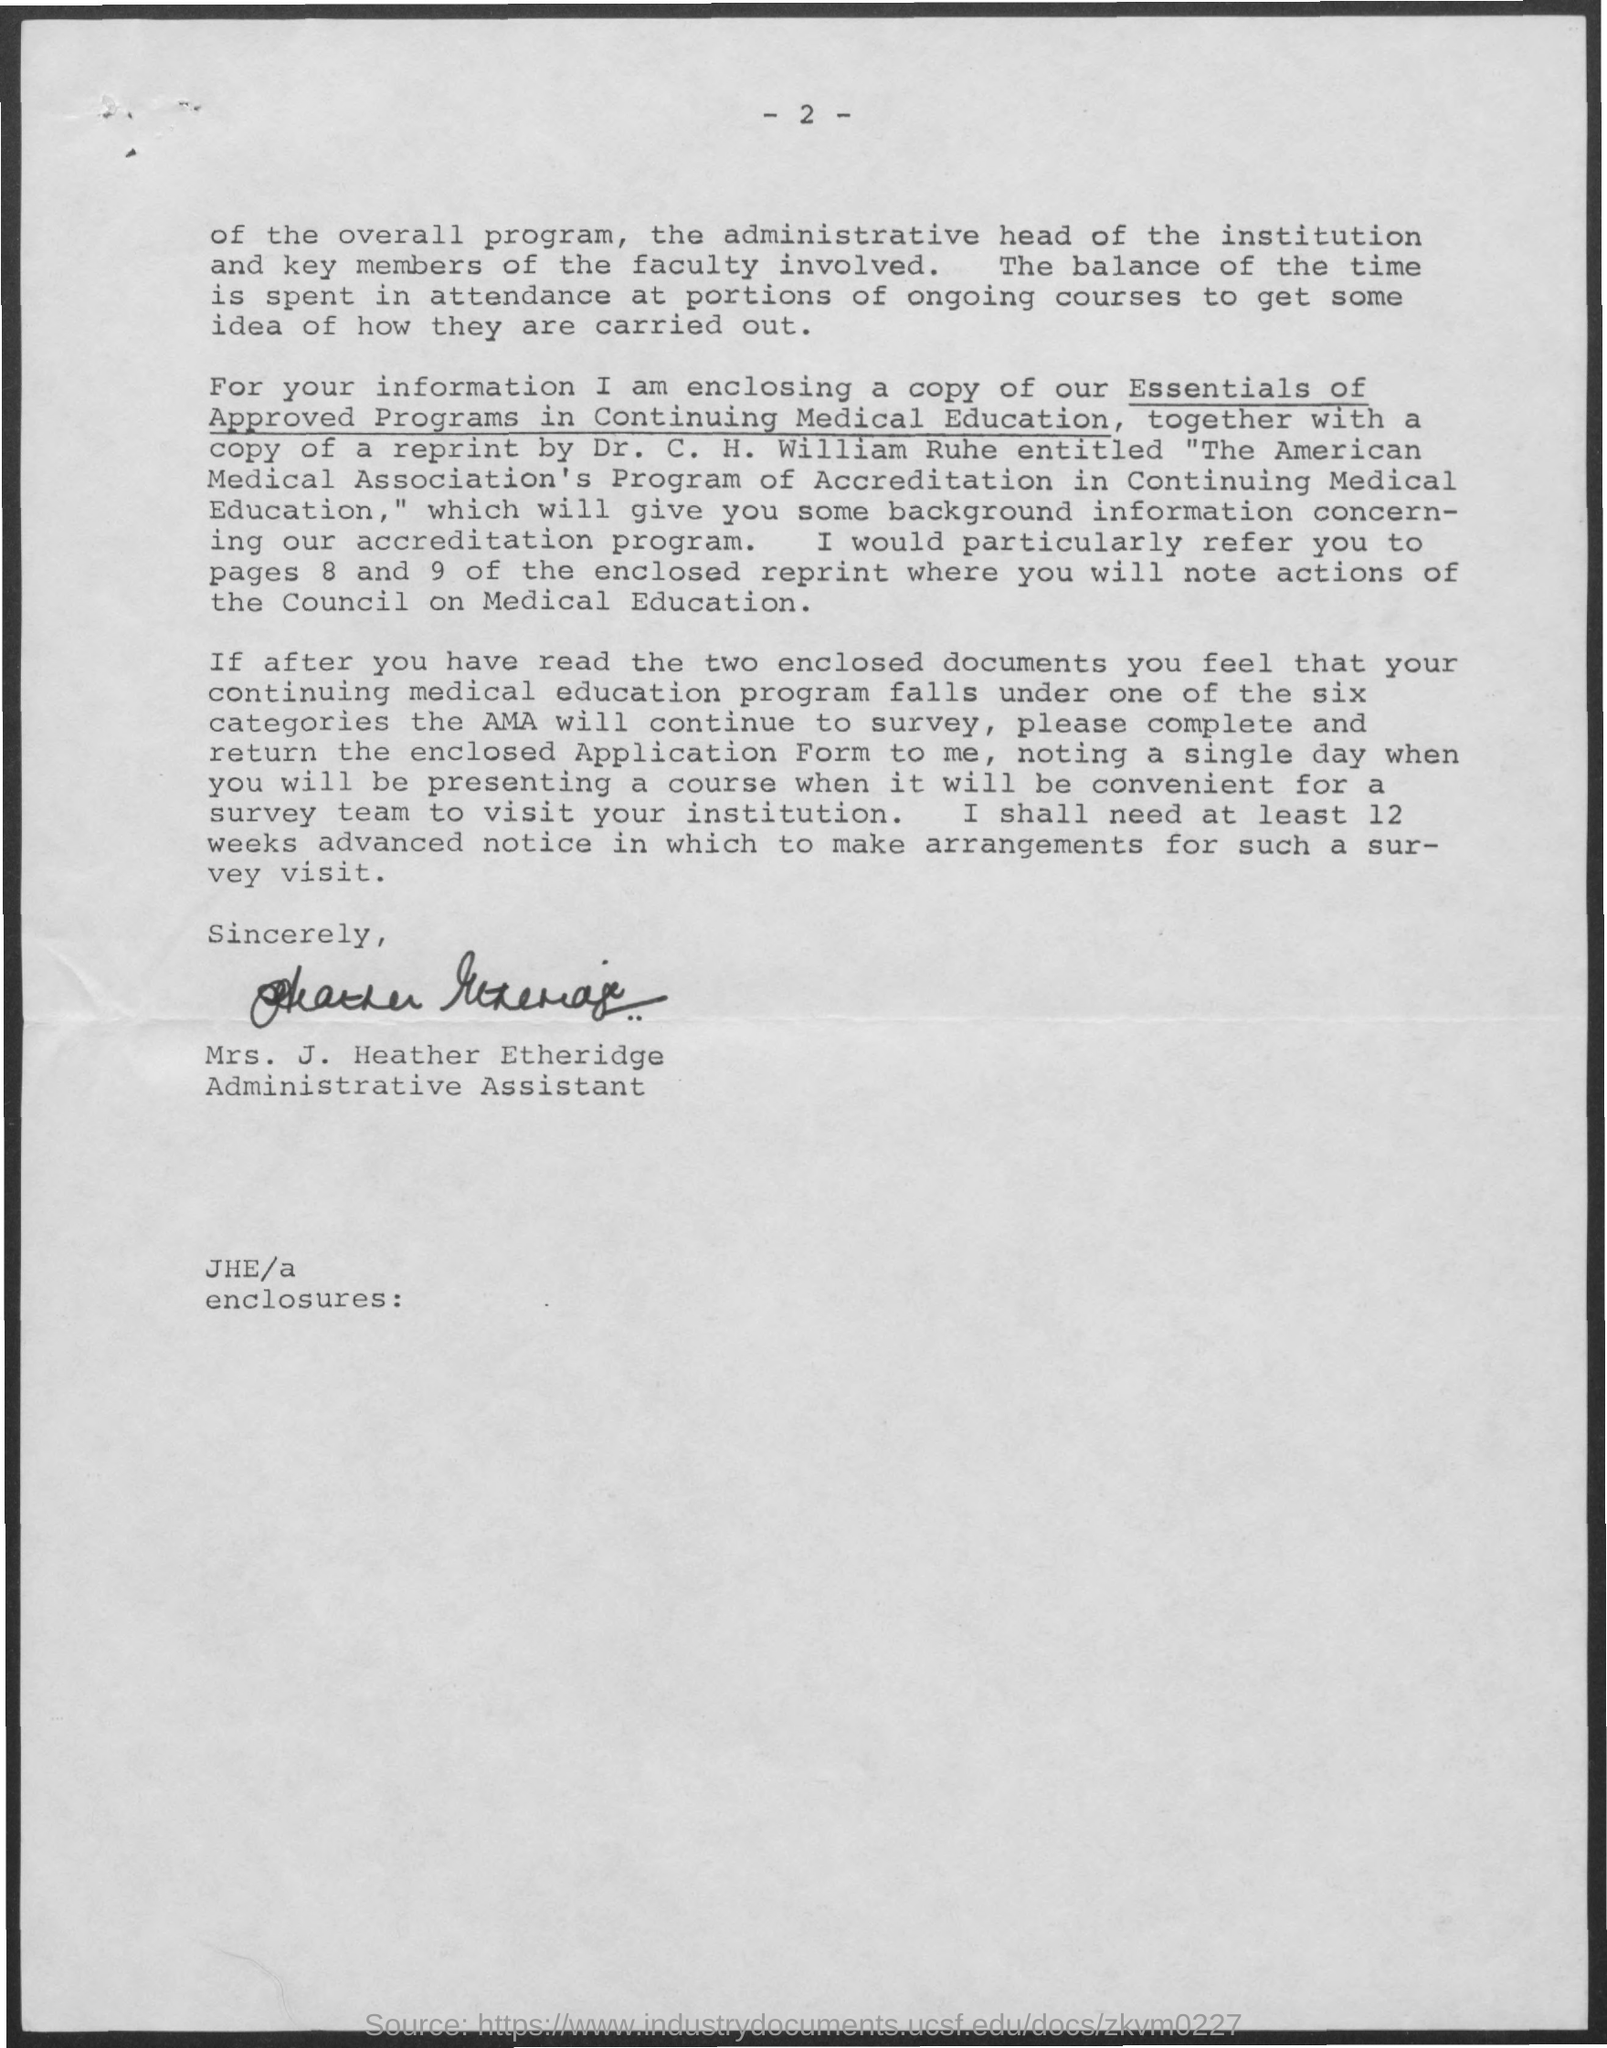Highlight a few significant elements in this photo. The declaration states that the document has been signed by Mrs. J. Heather Etheridge. The page number mentioned in this document is 2," or "The second page of this document is... Mrs. J. Heather Etheridge is officially designated as an administrative assistant. 